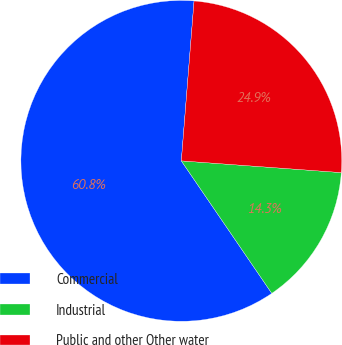Convert chart to OTSL. <chart><loc_0><loc_0><loc_500><loc_500><pie_chart><fcel>Commercial<fcel>Industrial<fcel>Public and other Other water<nl><fcel>60.8%<fcel>14.3%<fcel>24.9%<nl></chart> 